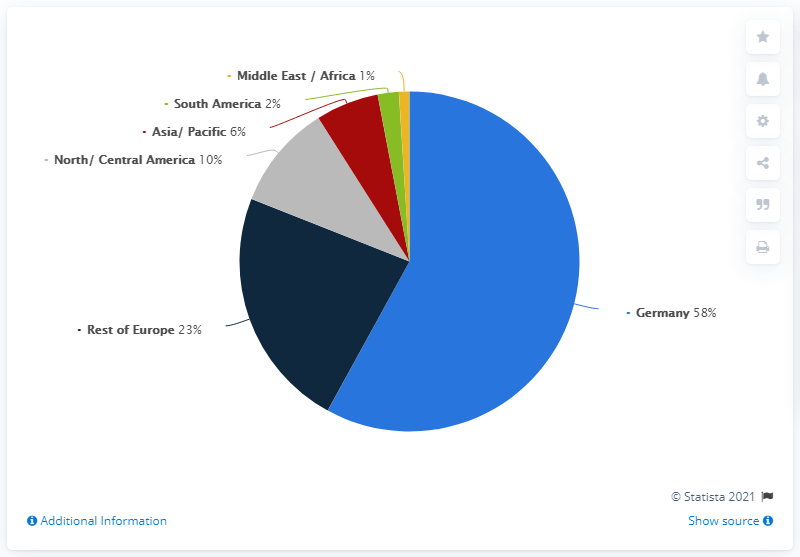List a handful of essential elements in this visual. In 2020, 58% of Lufthansa's employees were located in Germany. In the pie chart, the blue bar represents Germany. If we add a dark blue bar and a grey bar, the total value would be 33. 